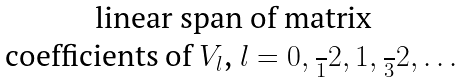Convert formula to latex. <formula><loc_0><loc_0><loc_500><loc_500>\begin{matrix} \text {linear span of matrix} \\ \text {coefficients of $V_{l}$, $l=0,\frac{ }{1}2, 1, \frac{ }{3}2,\dots$} \end{matrix}</formula> 